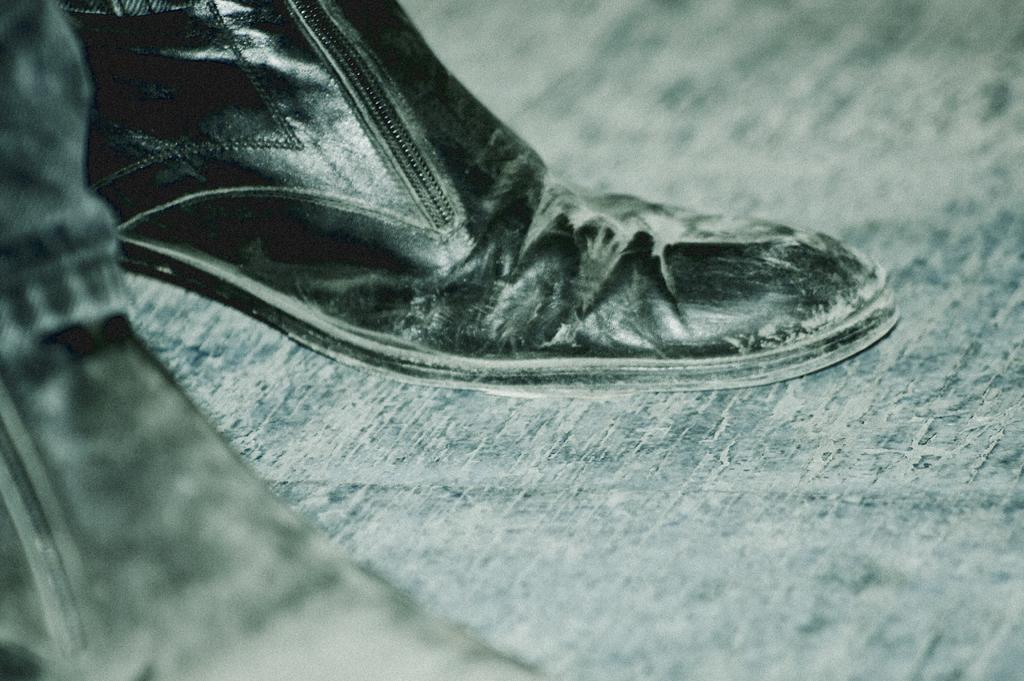What is placed on the floor in the image? There is a pair of shoes on the floor. What can be seen on the left side of the image? There is a cloth on the left side of the image. Can you see a rabbit hopping on the cloth in the image? There is no rabbit present in the image; only a pair of shoes on the floor and a cloth on the left side are visible. 